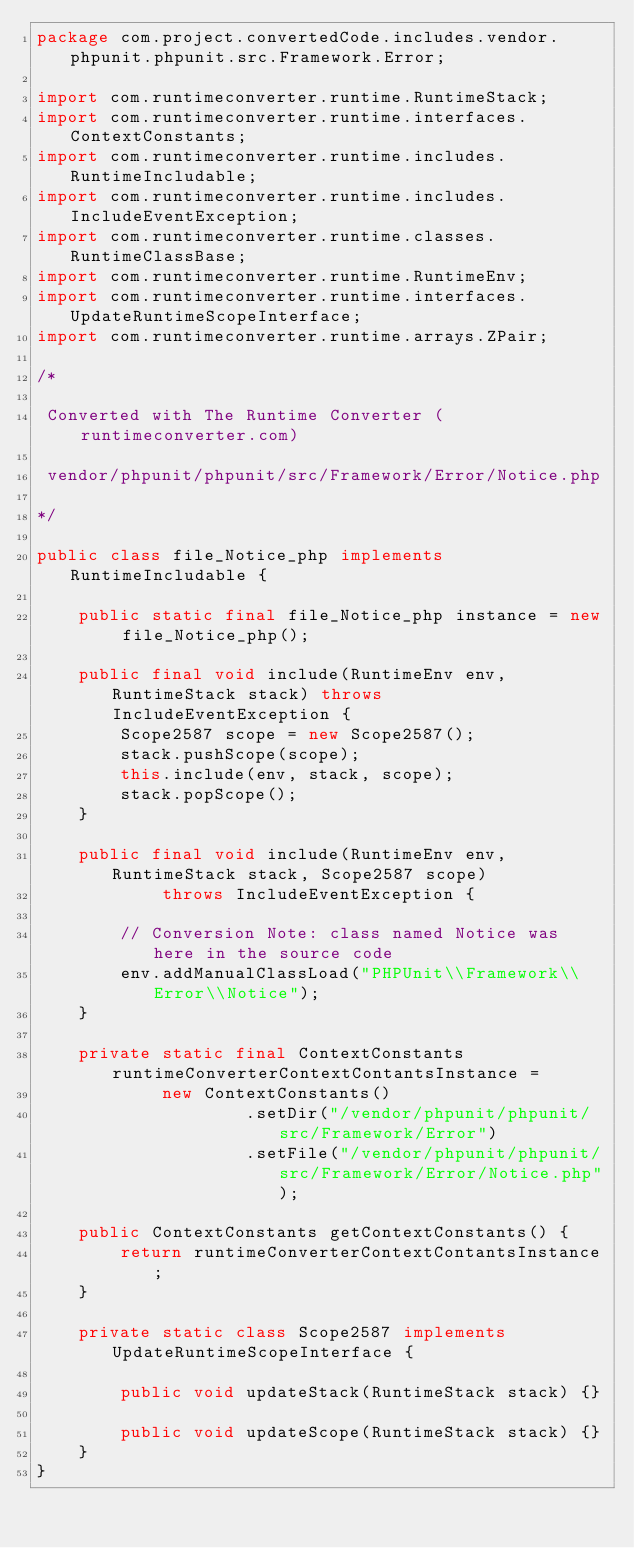<code> <loc_0><loc_0><loc_500><loc_500><_Java_>package com.project.convertedCode.includes.vendor.phpunit.phpunit.src.Framework.Error;

import com.runtimeconverter.runtime.RuntimeStack;
import com.runtimeconverter.runtime.interfaces.ContextConstants;
import com.runtimeconverter.runtime.includes.RuntimeIncludable;
import com.runtimeconverter.runtime.includes.IncludeEventException;
import com.runtimeconverter.runtime.classes.RuntimeClassBase;
import com.runtimeconverter.runtime.RuntimeEnv;
import com.runtimeconverter.runtime.interfaces.UpdateRuntimeScopeInterface;
import com.runtimeconverter.runtime.arrays.ZPair;

/*

 Converted with The Runtime Converter (runtimeconverter.com)

 vendor/phpunit/phpunit/src/Framework/Error/Notice.php

*/

public class file_Notice_php implements RuntimeIncludable {

    public static final file_Notice_php instance = new file_Notice_php();

    public final void include(RuntimeEnv env, RuntimeStack stack) throws IncludeEventException {
        Scope2587 scope = new Scope2587();
        stack.pushScope(scope);
        this.include(env, stack, scope);
        stack.popScope();
    }

    public final void include(RuntimeEnv env, RuntimeStack stack, Scope2587 scope)
            throws IncludeEventException {

        // Conversion Note: class named Notice was here in the source code
        env.addManualClassLoad("PHPUnit\\Framework\\Error\\Notice");
    }

    private static final ContextConstants runtimeConverterContextContantsInstance =
            new ContextConstants()
                    .setDir("/vendor/phpunit/phpunit/src/Framework/Error")
                    .setFile("/vendor/phpunit/phpunit/src/Framework/Error/Notice.php");

    public ContextConstants getContextConstants() {
        return runtimeConverterContextContantsInstance;
    }

    private static class Scope2587 implements UpdateRuntimeScopeInterface {

        public void updateStack(RuntimeStack stack) {}

        public void updateScope(RuntimeStack stack) {}
    }
}
</code> 